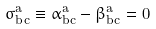<formula> <loc_0><loc_0><loc_500><loc_500>\sigma _ { b c } ^ { a } \equiv \alpha _ { b c } ^ { a } - \beta _ { b c } ^ { a } = 0</formula> 